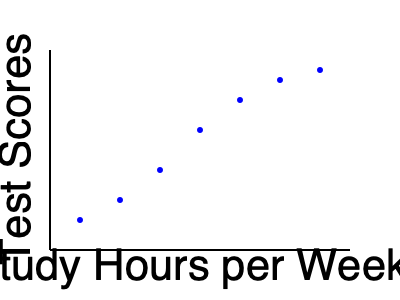As an education reform advocate, you're analyzing the relationship between study hours and test scores. Based on the scatter plot, what can you conclude about the correlation between study time and academic performance? To interpret this scatter plot and determine the correlation between study time and academic performance, we need to follow these steps:

1. Observe the overall trend: As we move from left to right (increasing study hours), the points generally move upward (higher test scores).

2. Assess the consistency: The upward trend is fairly consistent, with no significant outliers or clusters that deviate from the pattern.

3. Evaluate the strength: The points form a clear pattern, but they're not perfectly aligned. This suggests a strong, but not perfect, correlation.

4. Consider the shape: The relationship appears to be roughly linear, with a positive slope.

5. Interpret the educational implications: Students who study more tend to achieve higher test scores, indicating that increased study time is associated with better academic performance.

6. Recognize limitations: While there's a clear positive correlation, other factors may also influence test scores. The plot doesn't prove causation.

Given these observations, we can conclude that there is a strong positive correlation between study hours and test scores, suggesting that increased study time is associated with improved academic performance.
Answer: Strong positive correlation 